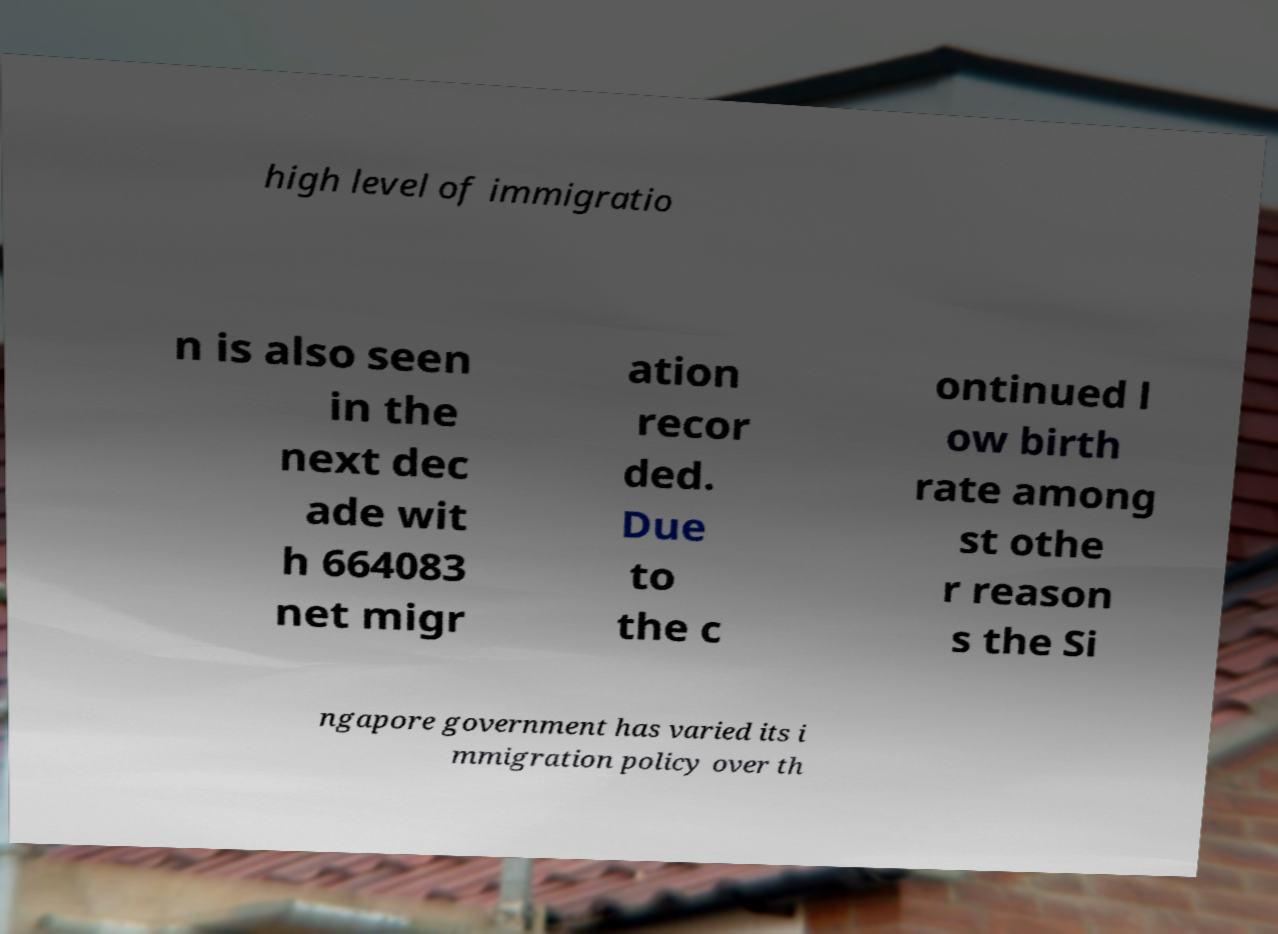Please identify and transcribe the text found in this image. high level of immigratio n is also seen in the next dec ade wit h 664083 net migr ation recor ded. Due to the c ontinued l ow birth rate among st othe r reason s the Si ngapore government has varied its i mmigration policy over th 